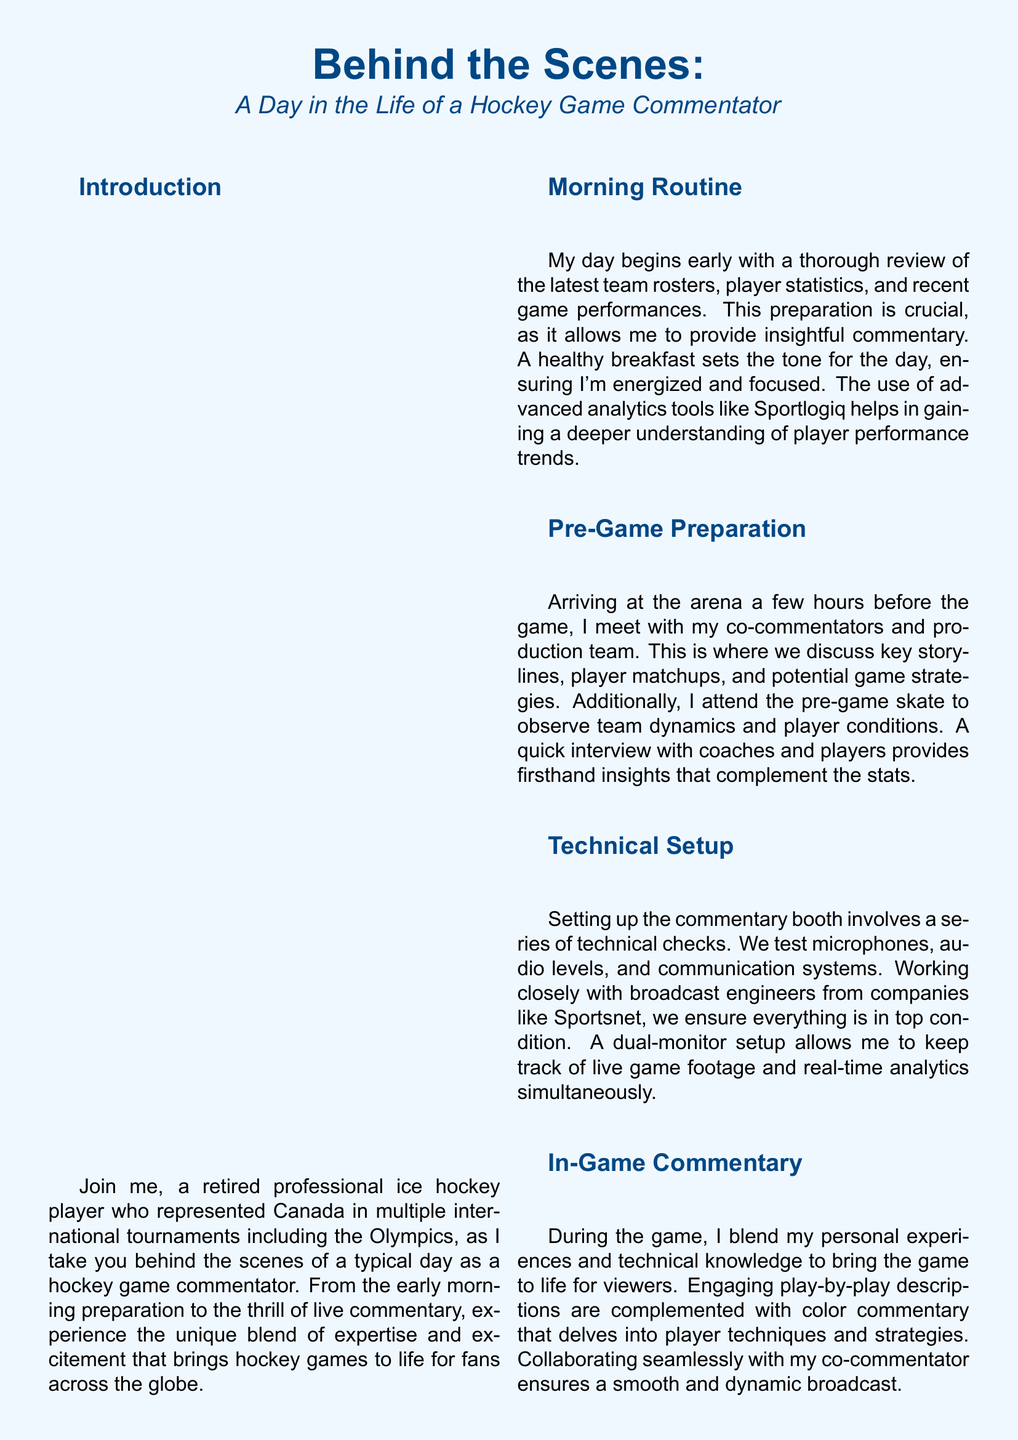What do you review in the morning? The document states that the commentator reviews the latest team rosters, player statistics, and recent game performances in the morning.
Answer: Team rosters, player statistics, recent game performances What is the role of advanced analytics tools like Sportlogiq? The use of advanced analytics tools helps in gaining a deeper understanding of player performance trends for insightful commentary.
Answer: Understanding player performance trends Who do you meet with before the game? The document mentions meeting with co-commentators and the production team before the game.
Answer: Co-commentators and production team What type of setup is used in the commentary booth? It is noted that a dual-monitor setup is used in the commentary booth to keep track of live game footage and real-time analytics.
Answer: Dual-monitor setup What happens after the final whistle? The commentator conducts quick post-game interviews and provides in-depth game analysis after the final whistle.
Answer: Quick post-game interviews and analysis How does playing career inform commentary? The retired player reflects that sharing experiences and insights provides a unique perspective that resonates with fans and adds depth to storytelling.
Answer: Unique perspective, depth to storytelling What is the color theme of the document? The document's color theme revolves around shades of blue, specifically ice hockey blue and an ice background.
Answer: Ice hockey blue and ice background What is included in the photo highlights section? The photo highlights section includes key moments such as preparing with statistics, setting up equipment, attending the pre-game skate, delivering commentary, and post-game analysis.
Answer: Preparing with statistics, setting up equipment, attending pre-game skate, delivering commentary, post-game analysis 